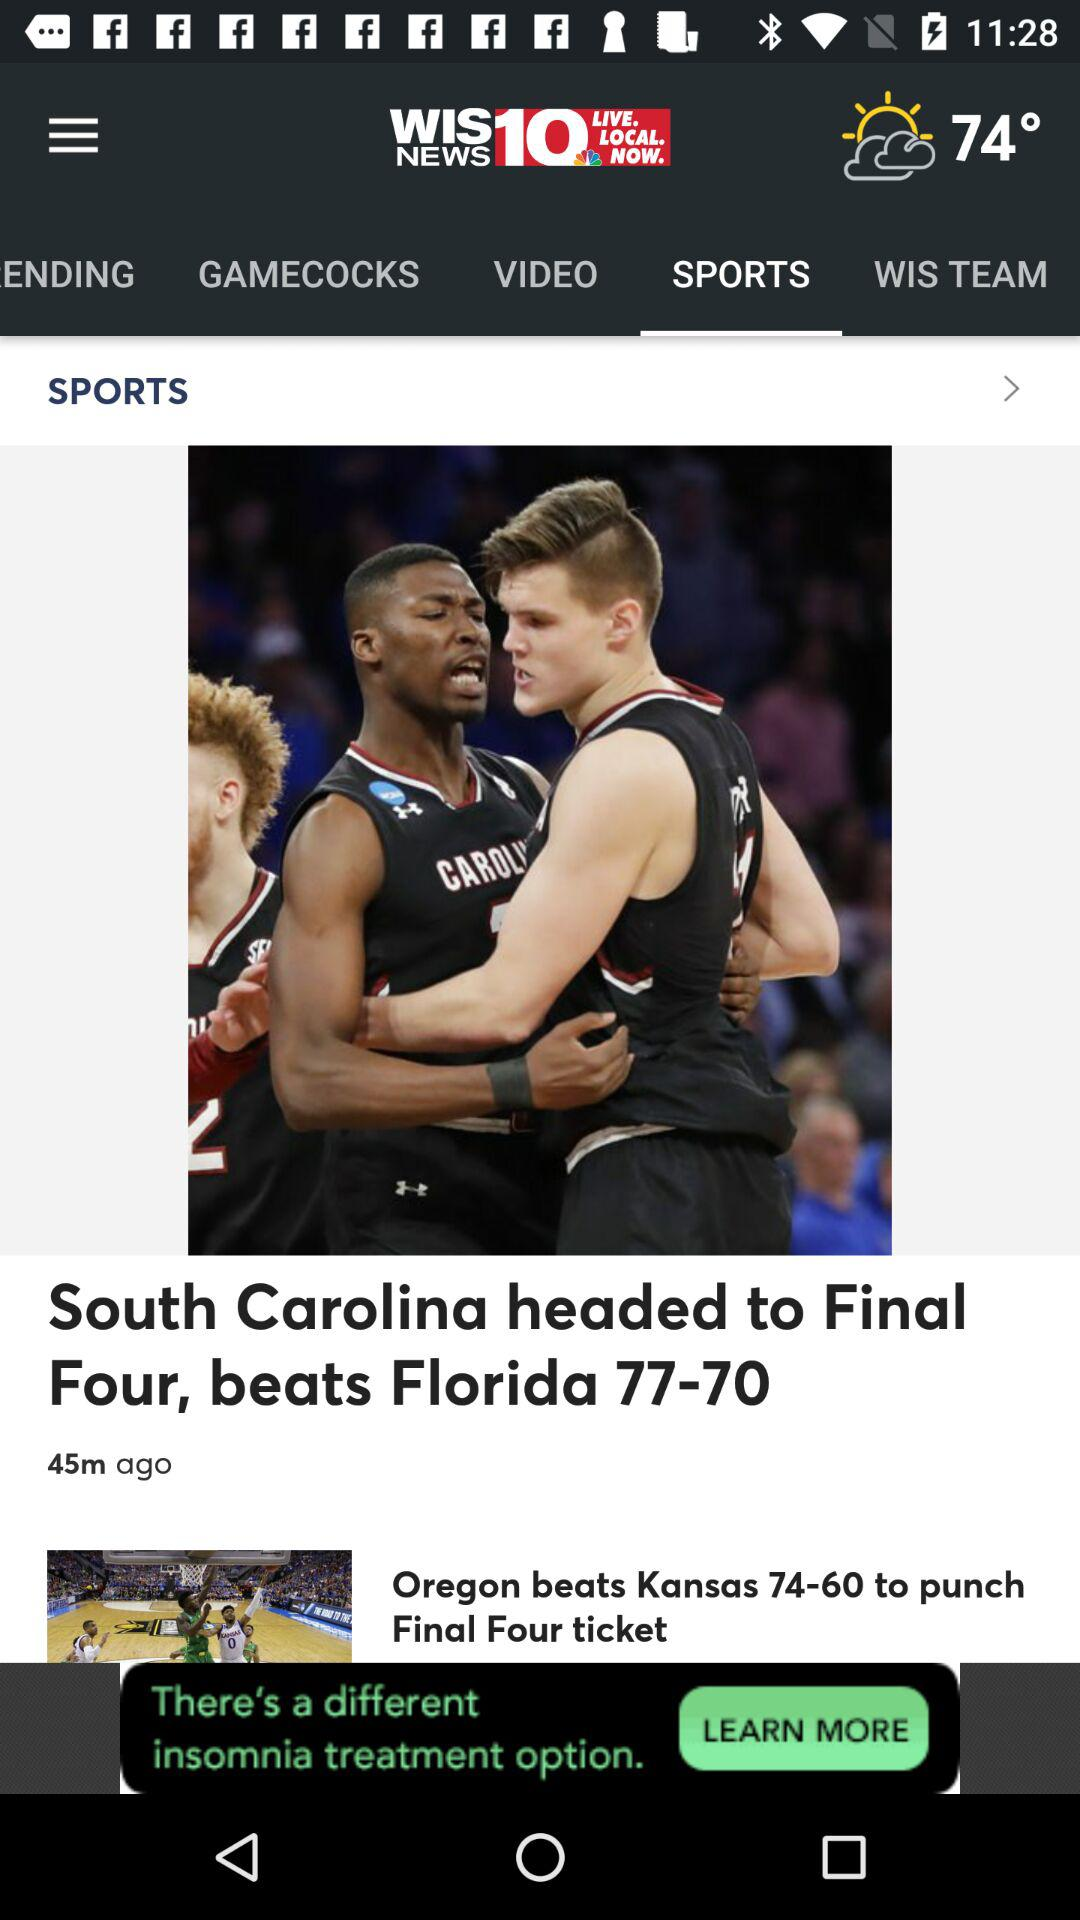How many minutes ago was the South Carolina game?
Answer the question using a single word or phrase. 45 